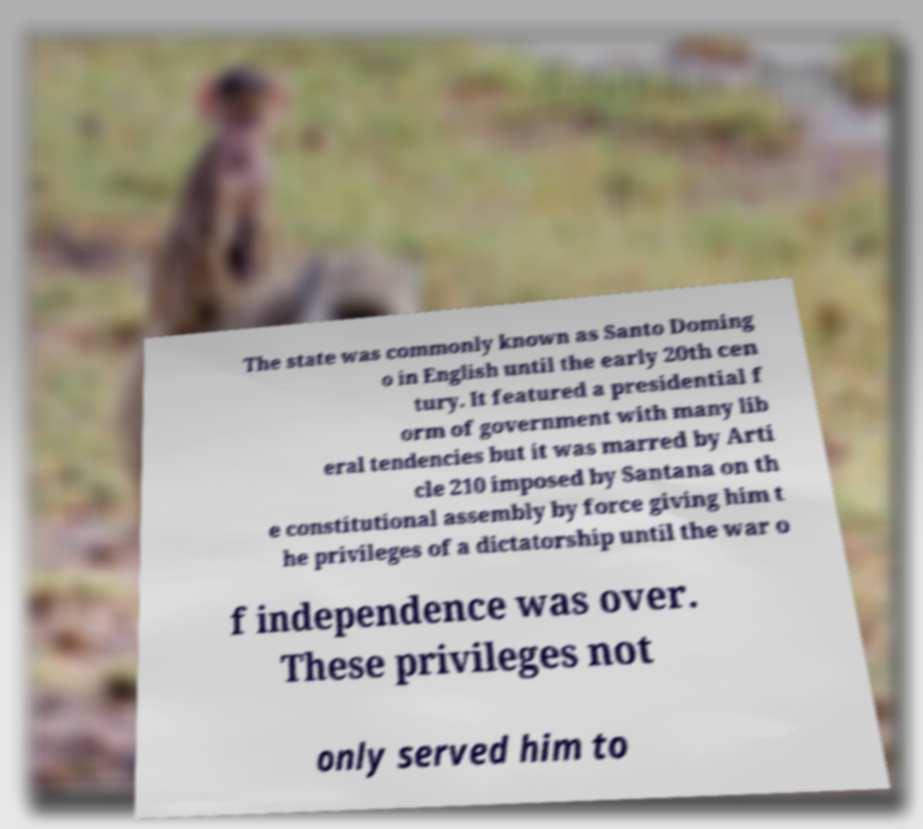Can you read and provide the text displayed in the image?This photo seems to have some interesting text. Can you extract and type it out for me? The state was commonly known as Santo Doming o in English until the early 20th cen tury. It featured a presidential f orm of government with many lib eral tendencies but it was marred by Arti cle 210 imposed by Santana on th e constitutional assembly by force giving him t he privileges of a dictatorship until the war o f independence was over. These privileges not only served him to 